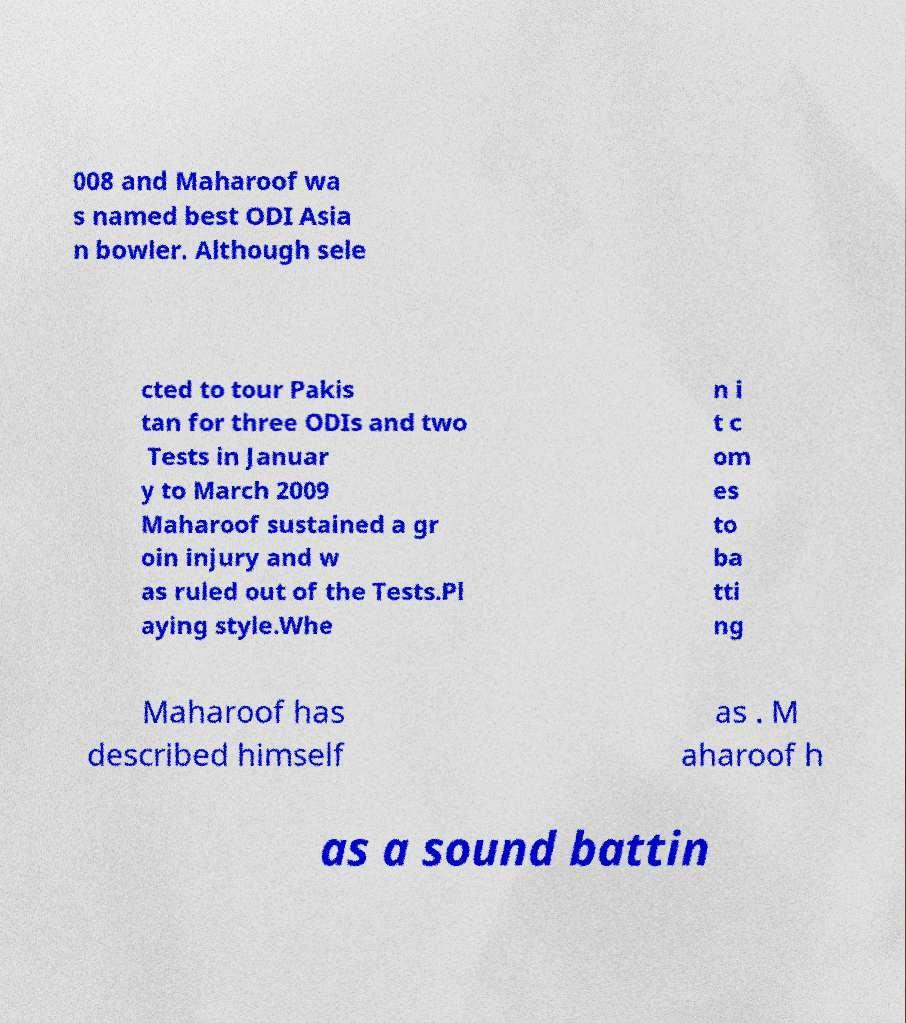For documentation purposes, I need the text within this image transcribed. Could you provide that? 008 and Maharoof wa s named best ODI Asia n bowler. Although sele cted to tour Pakis tan for three ODIs and two Tests in Januar y to March 2009 Maharoof sustained a gr oin injury and w as ruled out of the Tests.Pl aying style.Whe n i t c om es to ba tti ng Maharoof has described himself as . M aharoof h as a sound battin 